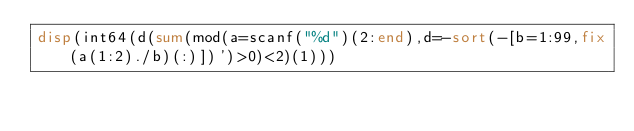Convert code to text. <code><loc_0><loc_0><loc_500><loc_500><_Octave_>disp(int64(d(sum(mod(a=scanf("%d")(2:end),d=-sort(-[b=1:99,fix(a(1:2)./b)(:)])')>0)<2)(1)))</code> 